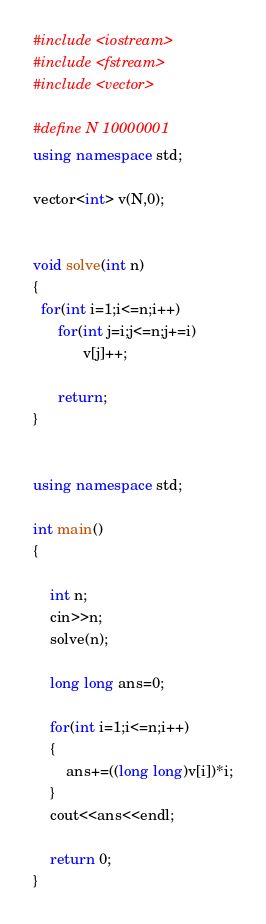<code> <loc_0><loc_0><loc_500><loc_500><_C++_>#include <iostream>
#include <fstream>
#include <vector>

#define N 10000001
using namespace std;

vector<int> v(N,0);


void solve(int n)
{
  for(int i=1;i<=n;i++)
  	  for(int j=i;j<=n;j+=i)
  	  		v[j]++;

      return;
}


using namespace std;

int main()
{

	int n;
	cin>>n;
	solve(n);

	long long ans=0;

	for(int i=1;i<=n;i++)
	{
		ans+=((long long)v[i])*i;
	}
	cout<<ans<<endl;

	return 0;
}</code> 